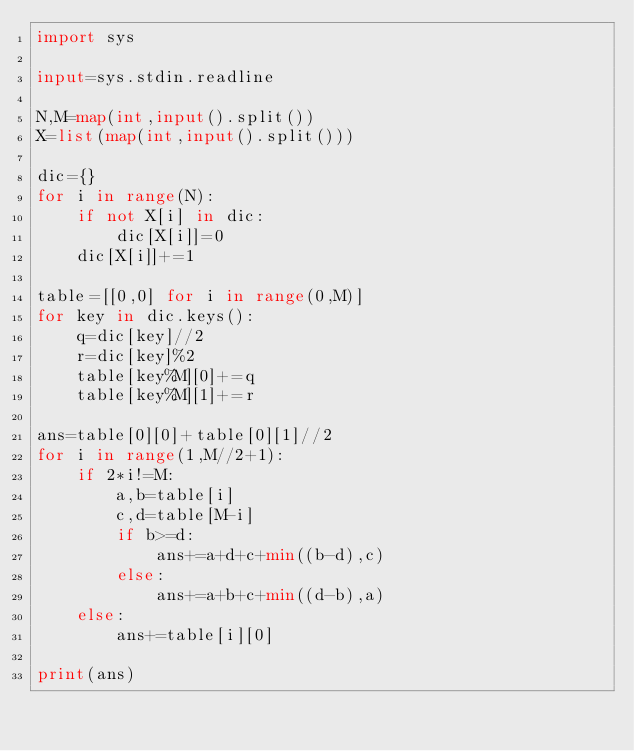Convert code to text. <code><loc_0><loc_0><loc_500><loc_500><_Python_>import sys

input=sys.stdin.readline

N,M=map(int,input().split())
X=list(map(int,input().split()))

dic={}
for i in range(N):
    if not X[i] in dic:
        dic[X[i]]=0
    dic[X[i]]+=1

table=[[0,0] for i in range(0,M)]
for key in dic.keys():
    q=dic[key]//2
    r=dic[key]%2
    table[key%M][0]+=q
    table[key%M][1]+=r

ans=table[0][0]+table[0][1]//2
for i in range(1,M//2+1):
    if 2*i!=M:
        a,b=table[i]
        c,d=table[M-i]
        if b>=d:
            ans+=a+d+c+min((b-d),c)
        else:
            ans+=a+b+c+min((d-b),a)
    else:
        ans+=table[i][0]

print(ans)
</code> 